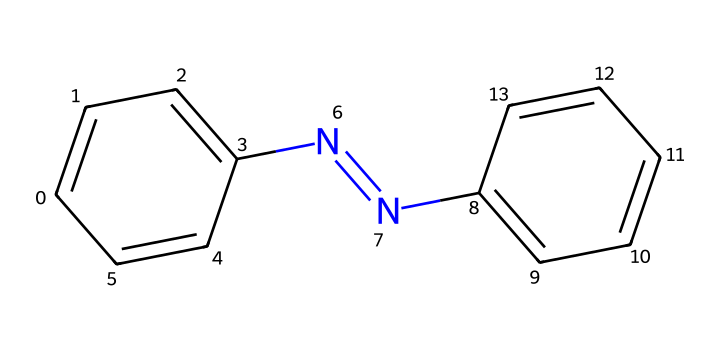What is the molecular formula of azobenzene? To determine the molecular formula, count the number of carbon (C), hydrogen (H), and nitrogen (N) atoms in the structured representation given by the SMILES. There are 12 carbons, 10 hydrogens, and 2 nitrogens.
Answer: C12H10N2 How many rings are present in azobenzene? The structure reveals that azobenzene consists of two phenyl rings connected by a nitrogen double bond. Each phenyl ring contributes one ring to the total count. Hence, there are two rings.
Answer: 2 What type of functional groups are present in azobenzene? The azobenzene molecule contains an azo functional group, characterized by the -N=N- bond, in addition to phenolic structures present in the two aromatic rings.
Answer: azo What does the presence of the azo group indicate about the chemical properties of azobenzene? The azo group contributes to the photoreactivity of azobenzene, specifically its ability to undergo reversible structural changes upon exposure to light, making it usable in smart materials and art.
Answer: photoreactivity How does the structure of azobenzene contribute to its switchable properties? Azobenzene's ability to undergo photoisomerization is facilitated by its planar structure when in the trans configuration, which can convert to a less planar cis form upon light absorption, effectively making it reversible to light stimuli.
Answer: isomerization What is the significance of azobenzene in art installations? Azobenzene's unique characteristic of responding to light changes allows artists to create dynamic installations where the visual appearance alters based on lighting conditions, integrating physical science with artistic expression.
Answer: dynamic installations 